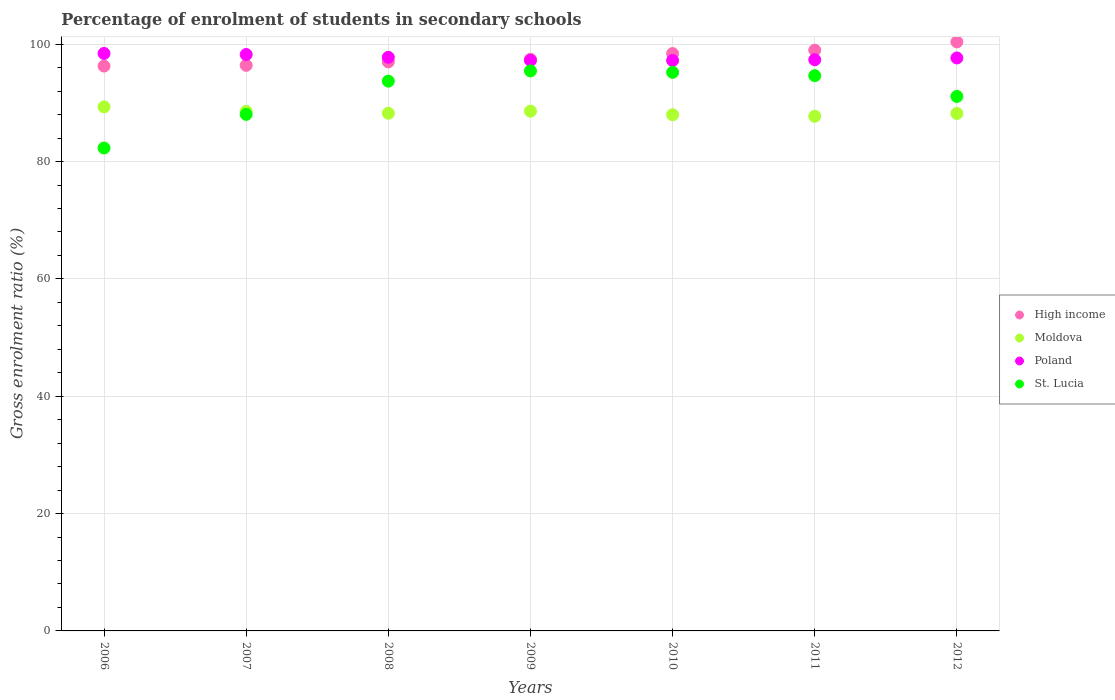Is the number of dotlines equal to the number of legend labels?
Offer a very short reply. Yes. What is the percentage of students enrolled in secondary schools in Moldova in 2007?
Offer a terse response. 88.55. Across all years, what is the maximum percentage of students enrolled in secondary schools in Poland?
Provide a succinct answer. 98.43. Across all years, what is the minimum percentage of students enrolled in secondary schools in Moldova?
Make the answer very short. 87.72. In which year was the percentage of students enrolled in secondary schools in St. Lucia maximum?
Provide a succinct answer. 2009. What is the total percentage of students enrolled in secondary schools in High income in the graph?
Your answer should be very brief. 684.9. What is the difference between the percentage of students enrolled in secondary schools in St. Lucia in 2006 and that in 2009?
Your response must be concise. -13.14. What is the difference between the percentage of students enrolled in secondary schools in Poland in 2006 and the percentage of students enrolled in secondary schools in St. Lucia in 2012?
Give a very brief answer. 7.33. What is the average percentage of students enrolled in secondary schools in St. Lucia per year?
Provide a succinct answer. 91.49. In the year 2009, what is the difference between the percentage of students enrolled in secondary schools in Moldova and percentage of students enrolled in secondary schools in St. Lucia?
Ensure brevity in your answer.  -6.85. In how many years, is the percentage of students enrolled in secondary schools in High income greater than 4 %?
Offer a terse response. 7. What is the ratio of the percentage of students enrolled in secondary schools in Poland in 2008 to that in 2009?
Provide a succinct answer. 1.01. Is the difference between the percentage of students enrolled in secondary schools in Moldova in 2008 and 2009 greater than the difference between the percentage of students enrolled in secondary schools in St. Lucia in 2008 and 2009?
Provide a short and direct response. Yes. What is the difference between the highest and the second highest percentage of students enrolled in secondary schools in Poland?
Your answer should be very brief. 0.18. What is the difference between the highest and the lowest percentage of students enrolled in secondary schools in Poland?
Offer a terse response. 1.21. In how many years, is the percentage of students enrolled in secondary schools in High income greater than the average percentage of students enrolled in secondary schools in High income taken over all years?
Ensure brevity in your answer.  3. Is it the case that in every year, the sum of the percentage of students enrolled in secondary schools in High income and percentage of students enrolled in secondary schools in Poland  is greater than the sum of percentage of students enrolled in secondary schools in Moldova and percentage of students enrolled in secondary schools in St. Lucia?
Give a very brief answer. Yes. Is the percentage of students enrolled in secondary schools in Moldova strictly greater than the percentage of students enrolled in secondary schools in Poland over the years?
Offer a very short reply. No. How many dotlines are there?
Make the answer very short. 4. Are the values on the major ticks of Y-axis written in scientific E-notation?
Your answer should be compact. No. Does the graph contain any zero values?
Your response must be concise. No. Where does the legend appear in the graph?
Your answer should be compact. Center right. How many legend labels are there?
Ensure brevity in your answer.  4. What is the title of the graph?
Your answer should be compact. Percentage of enrolment of students in secondary schools. What is the label or title of the X-axis?
Make the answer very short. Years. What is the Gross enrolment ratio (%) in High income in 2006?
Ensure brevity in your answer.  96.28. What is the Gross enrolment ratio (%) of Moldova in 2006?
Provide a short and direct response. 89.32. What is the Gross enrolment ratio (%) of Poland in 2006?
Ensure brevity in your answer.  98.43. What is the Gross enrolment ratio (%) in St. Lucia in 2006?
Your answer should be compact. 82.31. What is the Gross enrolment ratio (%) in High income in 2007?
Ensure brevity in your answer.  96.4. What is the Gross enrolment ratio (%) of Moldova in 2007?
Keep it short and to the point. 88.55. What is the Gross enrolment ratio (%) in Poland in 2007?
Your response must be concise. 98.25. What is the Gross enrolment ratio (%) in St. Lucia in 2007?
Offer a terse response. 88.04. What is the Gross enrolment ratio (%) in High income in 2008?
Keep it short and to the point. 96.99. What is the Gross enrolment ratio (%) in Moldova in 2008?
Your answer should be very brief. 88.23. What is the Gross enrolment ratio (%) in Poland in 2008?
Provide a succinct answer. 97.77. What is the Gross enrolment ratio (%) of St. Lucia in 2008?
Offer a very short reply. 93.71. What is the Gross enrolment ratio (%) of High income in 2009?
Your answer should be very brief. 97.44. What is the Gross enrolment ratio (%) of Moldova in 2009?
Offer a very short reply. 88.6. What is the Gross enrolment ratio (%) in Poland in 2009?
Provide a short and direct response. 97.25. What is the Gross enrolment ratio (%) in St. Lucia in 2009?
Ensure brevity in your answer.  95.45. What is the Gross enrolment ratio (%) of High income in 2010?
Your response must be concise. 98.41. What is the Gross enrolment ratio (%) in Moldova in 2010?
Your answer should be compact. 87.98. What is the Gross enrolment ratio (%) of Poland in 2010?
Your answer should be very brief. 97.22. What is the Gross enrolment ratio (%) of St. Lucia in 2010?
Your answer should be compact. 95.21. What is the Gross enrolment ratio (%) of High income in 2011?
Ensure brevity in your answer.  98.98. What is the Gross enrolment ratio (%) of Moldova in 2011?
Keep it short and to the point. 87.72. What is the Gross enrolment ratio (%) of Poland in 2011?
Provide a short and direct response. 97.36. What is the Gross enrolment ratio (%) in St. Lucia in 2011?
Make the answer very short. 94.64. What is the Gross enrolment ratio (%) in High income in 2012?
Offer a terse response. 100.4. What is the Gross enrolment ratio (%) in Moldova in 2012?
Your answer should be compact. 88.2. What is the Gross enrolment ratio (%) in Poland in 2012?
Offer a very short reply. 97.66. What is the Gross enrolment ratio (%) in St. Lucia in 2012?
Give a very brief answer. 91.1. Across all years, what is the maximum Gross enrolment ratio (%) in High income?
Your answer should be compact. 100.4. Across all years, what is the maximum Gross enrolment ratio (%) of Moldova?
Ensure brevity in your answer.  89.32. Across all years, what is the maximum Gross enrolment ratio (%) of Poland?
Offer a very short reply. 98.43. Across all years, what is the maximum Gross enrolment ratio (%) in St. Lucia?
Your answer should be compact. 95.45. Across all years, what is the minimum Gross enrolment ratio (%) of High income?
Your answer should be compact. 96.28. Across all years, what is the minimum Gross enrolment ratio (%) in Moldova?
Your response must be concise. 87.72. Across all years, what is the minimum Gross enrolment ratio (%) in Poland?
Keep it short and to the point. 97.22. Across all years, what is the minimum Gross enrolment ratio (%) of St. Lucia?
Your answer should be very brief. 82.31. What is the total Gross enrolment ratio (%) of High income in the graph?
Provide a succinct answer. 684.9. What is the total Gross enrolment ratio (%) of Moldova in the graph?
Your response must be concise. 618.6. What is the total Gross enrolment ratio (%) in Poland in the graph?
Your response must be concise. 683.93. What is the total Gross enrolment ratio (%) of St. Lucia in the graph?
Ensure brevity in your answer.  640.46. What is the difference between the Gross enrolment ratio (%) of High income in 2006 and that in 2007?
Your answer should be compact. -0.12. What is the difference between the Gross enrolment ratio (%) in Moldova in 2006 and that in 2007?
Make the answer very short. 0.77. What is the difference between the Gross enrolment ratio (%) in Poland in 2006 and that in 2007?
Give a very brief answer. 0.18. What is the difference between the Gross enrolment ratio (%) in St. Lucia in 2006 and that in 2007?
Your answer should be compact. -5.73. What is the difference between the Gross enrolment ratio (%) of High income in 2006 and that in 2008?
Offer a terse response. -0.71. What is the difference between the Gross enrolment ratio (%) of Moldova in 2006 and that in 2008?
Make the answer very short. 1.09. What is the difference between the Gross enrolment ratio (%) of Poland in 2006 and that in 2008?
Provide a short and direct response. 0.66. What is the difference between the Gross enrolment ratio (%) in St. Lucia in 2006 and that in 2008?
Provide a short and direct response. -11.4. What is the difference between the Gross enrolment ratio (%) of High income in 2006 and that in 2009?
Provide a succinct answer. -1.16. What is the difference between the Gross enrolment ratio (%) of Moldova in 2006 and that in 2009?
Make the answer very short. 0.73. What is the difference between the Gross enrolment ratio (%) of Poland in 2006 and that in 2009?
Provide a short and direct response. 1.18. What is the difference between the Gross enrolment ratio (%) of St. Lucia in 2006 and that in 2009?
Your answer should be very brief. -13.14. What is the difference between the Gross enrolment ratio (%) of High income in 2006 and that in 2010?
Provide a succinct answer. -2.13. What is the difference between the Gross enrolment ratio (%) of Moldova in 2006 and that in 2010?
Provide a succinct answer. 1.34. What is the difference between the Gross enrolment ratio (%) in Poland in 2006 and that in 2010?
Provide a succinct answer. 1.21. What is the difference between the Gross enrolment ratio (%) of St. Lucia in 2006 and that in 2010?
Your answer should be very brief. -12.9. What is the difference between the Gross enrolment ratio (%) of High income in 2006 and that in 2011?
Ensure brevity in your answer.  -2.71. What is the difference between the Gross enrolment ratio (%) of Moldova in 2006 and that in 2011?
Your answer should be very brief. 1.6. What is the difference between the Gross enrolment ratio (%) of Poland in 2006 and that in 2011?
Your answer should be compact. 1.07. What is the difference between the Gross enrolment ratio (%) of St. Lucia in 2006 and that in 2011?
Ensure brevity in your answer.  -12.33. What is the difference between the Gross enrolment ratio (%) in High income in 2006 and that in 2012?
Give a very brief answer. -4.12. What is the difference between the Gross enrolment ratio (%) in Moldova in 2006 and that in 2012?
Ensure brevity in your answer.  1.13. What is the difference between the Gross enrolment ratio (%) of Poland in 2006 and that in 2012?
Make the answer very short. 0.77. What is the difference between the Gross enrolment ratio (%) of St. Lucia in 2006 and that in 2012?
Your response must be concise. -8.79. What is the difference between the Gross enrolment ratio (%) of High income in 2007 and that in 2008?
Offer a very short reply. -0.59. What is the difference between the Gross enrolment ratio (%) in Moldova in 2007 and that in 2008?
Keep it short and to the point. 0.32. What is the difference between the Gross enrolment ratio (%) of Poland in 2007 and that in 2008?
Give a very brief answer. 0.47. What is the difference between the Gross enrolment ratio (%) of St. Lucia in 2007 and that in 2008?
Provide a succinct answer. -5.67. What is the difference between the Gross enrolment ratio (%) of High income in 2007 and that in 2009?
Offer a terse response. -1.04. What is the difference between the Gross enrolment ratio (%) in Moldova in 2007 and that in 2009?
Ensure brevity in your answer.  -0.04. What is the difference between the Gross enrolment ratio (%) in Poland in 2007 and that in 2009?
Ensure brevity in your answer.  1. What is the difference between the Gross enrolment ratio (%) in St. Lucia in 2007 and that in 2009?
Ensure brevity in your answer.  -7.41. What is the difference between the Gross enrolment ratio (%) of High income in 2007 and that in 2010?
Provide a short and direct response. -2.01. What is the difference between the Gross enrolment ratio (%) in Moldova in 2007 and that in 2010?
Give a very brief answer. 0.57. What is the difference between the Gross enrolment ratio (%) in Poland in 2007 and that in 2010?
Make the answer very short. 1.03. What is the difference between the Gross enrolment ratio (%) of St. Lucia in 2007 and that in 2010?
Provide a short and direct response. -7.17. What is the difference between the Gross enrolment ratio (%) of High income in 2007 and that in 2011?
Offer a terse response. -2.59. What is the difference between the Gross enrolment ratio (%) in Moldova in 2007 and that in 2011?
Keep it short and to the point. 0.83. What is the difference between the Gross enrolment ratio (%) of Poland in 2007 and that in 2011?
Provide a succinct answer. 0.89. What is the difference between the Gross enrolment ratio (%) of St. Lucia in 2007 and that in 2011?
Provide a short and direct response. -6.6. What is the difference between the Gross enrolment ratio (%) of High income in 2007 and that in 2012?
Provide a short and direct response. -4. What is the difference between the Gross enrolment ratio (%) of Moldova in 2007 and that in 2012?
Offer a very short reply. 0.36. What is the difference between the Gross enrolment ratio (%) of Poland in 2007 and that in 2012?
Give a very brief answer. 0.59. What is the difference between the Gross enrolment ratio (%) in St. Lucia in 2007 and that in 2012?
Make the answer very short. -3.06. What is the difference between the Gross enrolment ratio (%) in High income in 2008 and that in 2009?
Make the answer very short. -0.45. What is the difference between the Gross enrolment ratio (%) of Moldova in 2008 and that in 2009?
Give a very brief answer. -0.36. What is the difference between the Gross enrolment ratio (%) in Poland in 2008 and that in 2009?
Ensure brevity in your answer.  0.53. What is the difference between the Gross enrolment ratio (%) in St. Lucia in 2008 and that in 2009?
Provide a short and direct response. -1.74. What is the difference between the Gross enrolment ratio (%) in High income in 2008 and that in 2010?
Your response must be concise. -1.42. What is the difference between the Gross enrolment ratio (%) of Moldova in 2008 and that in 2010?
Keep it short and to the point. 0.25. What is the difference between the Gross enrolment ratio (%) in Poland in 2008 and that in 2010?
Make the answer very short. 0.55. What is the difference between the Gross enrolment ratio (%) in St. Lucia in 2008 and that in 2010?
Provide a short and direct response. -1.5. What is the difference between the Gross enrolment ratio (%) of High income in 2008 and that in 2011?
Provide a succinct answer. -1.99. What is the difference between the Gross enrolment ratio (%) in Moldova in 2008 and that in 2011?
Make the answer very short. 0.52. What is the difference between the Gross enrolment ratio (%) in Poland in 2008 and that in 2011?
Your answer should be very brief. 0.42. What is the difference between the Gross enrolment ratio (%) of St. Lucia in 2008 and that in 2011?
Keep it short and to the point. -0.93. What is the difference between the Gross enrolment ratio (%) in High income in 2008 and that in 2012?
Your response must be concise. -3.41. What is the difference between the Gross enrolment ratio (%) in Moldova in 2008 and that in 2012?
Provide a short and direct response. 0.04. What is the difference between the Gross enrolment ratio (%) in Poland in 2008 and that in 2012?
Offer a very short reply. 0.11. What is the difference between the Gross enrolment ratio (%) in St. Lucia in 2008 and that in 2012?
Offer a terse response. 2.61. What is the difference between the Gross enrolment ratio (%) of High income in 2009 and that in 2010?
Make the answer very short. -0.97. What is the difference between the Gross enrolment ratio (%) in Moldova in 2009 and that in 2010?
Provide a short and direct response. 0.62. What is the difference between the Gross enrolment ratio (%) in Poland in 2009 and that in 2010?
Provide a short and direct response. 0.02. What is the difference between the Gross enrolment ratio (%) of St. Lucia in 2009 and that in 2010?
Make the answer very short. 0.24. What is the difference between the Gross enrolment ratio (%) of High income in 2009 and that in 2011?
Ensure brevity in your answer.  -1.55. What is the difference between the Gross enrolment ratio (%) of Moldova in 2009 and that in 2011?
Make the answer very short. 0.88. What is the difference between the Gross enrolment ratio (%) in Poland in 2009 and that in 2011?
Make the answer very short. -0.11. What is the difference between the Gross enrolment ratio (%) in St. Lucia in 2009 and that in 2011?
Provide a succinct answer. 0.81. What is the difference between the Gross enrolment ratio (%) of High income in 2009 and that in 2012?
Provide a succinct answer. -2.96. What is the difference between the Gross enrolment ratio (%) of Moldova in 2009 and that in 2012?
Your response must be concise. 0.4. What is the difference between the Gross enrolment ratio (%) of Poland in 2009 and that in 2012?
Keep it short and to the point. -0.41. What is the difference between the Gross enrolment ratio (%) of St. Lucia in 2009 and that in 2012?
Keep it short and to the point. 4.35. What is the difference between the Gross enrolment ratio (%) of High income in 2010 and that in 2011?
Provide a succinct answer. -0.58. What is the difference between the Gross enrolment ratio (%) of Moldova in 2010 and that in 2011?
Keep it short and to the point. 0.26. What is the difference between the Gross enrolment ratio (%) of Poland in 2010 and that in 2011?
Your answer should be very brief. -0.13. What is the difference between the Gross enrolment ratio (%) of St. Lucia in 2010 and that in 2011?
Offer a terse response. 0.57. What is the difference between the Gross enrolment ratio (%) in High income in 2010 and that in 2012?
Provide a succinct answer. -1.99. What is the difference between the Gross enrolment ratio (%) of Moldova in 2010 and that in 2012?
Give a very brief answer. -0.21. What is the difference between the Gross enrolment ratio (%) of Poland in 2010 and that in 2012?
Give a very brief answer. -0.44. What is the difference between the Gross enrolment ratio (%) in St. Lucia in 2010 and that in 2012?
Provide a short and direct response. 4.11. What is the difference between the Gross enrolment ratio (%) of High income in 2011 and that in 2012?
Offer a terse response. -1.41. What is the difference between the Gross enrolment ratio (%) of Moldova in 2011 and that in 2012?
Your response must be concise. -0.48. What is the difference between the Gross enrolment ratio (%) of Poland in 2011 and that in 2012?
Keep it short and to the point. -0.3. What is the difference between the Gross enrolment ratio (%) in St. Lucia in 2011 and that in 2012?
Ensure brevity in your answer.  3.54. What is the difference between the Gross enrolment ratio (%) of High income in 2006 and the Gross enrolment ratio (%) of Moldova in 2007?
Give a very brief answer. 7.72. What is the difference between the Gross enrolment ratio (%) in High income in 2006 and the Gross enrolment ratio (%) in Poland in 2007?
Your answer should be compact. -1.97. What is the difference between the Gross enrolment ratio (%) in High income in 2006 and the Gross enrolment ratio (%) in St. Lucia in 2007?
Your response must be concise. 8.23. What is the difference between the Gross enrolment ratio (%) of Moldova in 2006 and the Gross enrolment ratio (%) of Poland in 2007?
Provide a succinct answer. -8.93. What is the difference between the Gross enrolment ratio (%) in Moldova in 2006 and the Gross enrolment ratio (%) in St. Lucia in 2007?
Your response must be concise. 1.28. What is the difference between the Gross enrolment ratio (%) in Poland in 2006 and the Gross enrolment ratio (%) in St. Lucia in 2007?
Provide a succinct answer. 10.38. What is the difference between the Gross enrolment ratio (%) in High income in 2006 and the Gross enrolment ratio (%) in Moldova in 2008?
Your answer should be compact. 8.04. What is the difference between the Gross enrolment ratio (%) of High income in 2006 and the Gross enrolment ratio (%) of Poland in 2008?
Offer a very short reply. -1.49. What is the difference between the Gross enrolment ratio (%) in High income in 2006 and the Gross enrolment ratio (%) in St. Lucia in 2008?
Your answer should be compact. 2.57. What is the difference between the Gross enrolment ratio (%) of Moldova in 2006 and the Gross enrolment ratio (%) of Poland in 2008?
Make the answer very short. -8.45. What is the difference between the Gross enrolment ratio (%) of Moldova in 2006 and the Gross enrolment ratio (%) of St. Lucia in 2008?
Your response must be concise. -4.39. What is the difference between the Gross enrolment ratio (%) of Poland in 2006 and the Gross enrolment ratio (%) of St. Lucia in 2008?
Provide a short and direct response. 4.72. What is the difference between the Gross enrolment ratio (%) of High income in 2006 and the Gross enrolment ratio (%) of Moldova in 2009?
Keep it short and to the point. 7.68. What is the difference between the Gross enrolment ratio (%) of High income in 2006 and the Gross enrolment ratio (%) of Poland in 2009?
Offer a terse response. -0.97. What is the difference between the Gross enrolment ratio (%) in High income in 2006 and the Gross enrolment ratio (%) in St. Lucia in 2009?
Your answer should be very brief. 0.83. What is the difference between the Gross enrolment ratio (%) of Moldova in 2006 and the Gross enrolment ratio (%) of Poland in 2009?
Your response must be concise. -7.92. What is the difference between the Gross enrolment ratio (%) of Moldova in 2006 and the Gross enrolment ratio (%) of St. Lucia in 2009?
Give a very brief answer. -6.13. What is the difference between the Gross enrolment ratio (%) in Poland in 2006 and the Gross enrolment ratio (%) in St. Lucia in 2009?
Offer a very short reply. 2.98. What is the difference between the Gross enrolment ratio (%) of High income in 2006 and the Gross enrolment ratio (%) of Moldova in 2010?
Keep it short and to the point. 8.3. What is the difference between the Gross enrolment ratio (%) in High income in 2006 and the Gross enrolment ratio (%) in Poland in 2010?
Make the answer very short. -0.94. What is the difference between the Gross enrolment ratio (%) of High income in 2006 and the Gross enrolment ratio (%) of St. Lucia in 2010?
Offer a very short reply. 1.07. What is the difference between the Gross enrolment ratio (%) in Moldova in 2006 and the Gross enrolment ratio (%) in Poland in 2010?
Offer a terse response. -7.9. What is the difference between the Gross enrolment ratio (%) in Moldova in 2006 and the Gross enrolment ratio (%) in St. Lucia in 2010?
Make the answer very short. -5.89. What is the difference between the Gross enrolment ratio (%) of Poland in 2006 and the Gross enrolment ratio (%) of St. Lucia in 2010?
Give a very brief answer. 3.22. What is the difference between the Gross enrolment ratio (%) in High income in 2006 and the Gross enrolment ratio (%) in Moldova in 2011?
Your answer should be compact. 8.56. What is the difference between the Gross enrolment ratio (%) of High income in 2006 and the Gross enrolment ratio (%) of Poland in 2011?
Keep it short and to the point. -1.08. What is the difference between the Gross enrolment ratio (%) in High income in 2006 and the Gross enrolment ratio (%) in St. Lucia in 2011?
Your response must be concise. 1.64. What is the difference between the Gross enrolment ratio (%) in Moldova in 2006 and the Gross enrolment ratio (%) in Poland in 2011?
Ensure brevity in your answer.  -8.03. What is the difference between the Gross enrolment ratio (%) in Moldova in 2006 and the Gross enrolment ratio (%) in St. Lucia in 2011?
Offer a terse response. -5.32. What is the difference between the Gross enrolment ratio (%) in Poland in 2006 and the Gross enrolment ratio (%) in St. Lucia in 2011?
Offer a very short reply. 3.79. What is the difference between the Gross enrolment ratio (%) in High income in 2006 and the Gross enrolment ratio (%) in Moldova in 2012?
Give a very brief answer. 8.08. What is the difference between the Gross enrolment ratio (%) in High income in 2006 and the Gross enrolment ratio (%) in Poland in 2012?
Provide a short and direct response. -1.38. What is the difference between the Gross enrolment ratio (%) of High income in 2006 and the Gross enrolment ratio (%) of St. Lucia in 2012?
Give a very brief answer. 5.18. What is the difference between the Gross enrolment ratio (%) in Moldova in 2006 and the Gross enrolment ratio (%) in Poland in 2012?
Your answer should be compact. -8.34. What is the difference between the Gross enrolment ratio (%) in Moldova in 2006 and the Gross enrolment ratio (%) in St. Lucia in 2012?
Make the answer very short. -1.78. What is the difference between the Gross enrolment ratio (%) of Poland in 2006 and the Gross enrolment ratio (%) of St. Lucia in 2012?
Give a very brief answer. 7.33. What is the difference between the Gross enrolment ratio (%) of High income in 2007 and the Gross enrolment ratio (%) of Moldova in 2008?
Provide a short and direct response. 8.16. What is the difference between the Gross enrolment ratio (%) of High income in 2007 and the Gross enrolment ratio (%) of Poland in 2008?
Offer a terse response. -1.37. What is the difference between the Gross enrolment ratio (%) of High income in 2007 and the Gross enrolment ratio (%) of St. Lucia in 2008?
Offer a very short reply. 2.69. What is the difference between the Gross enrolment ratio (%) in Moldova in 2007 and the Gross enrolment ratio (%) in Poland in 2008?
Ensure brevity in your answer.  -9.22. What is the difference between the Gross enrolment ratio (%) of Moldova in 2007 and the Gross enrolment ratio (%) of St. Lucia in 2008?
Your answer should be compact. -5.16. What is the difference between the Gross enrolment ratio (%) in Poland in 2007 and the Gross enrolment ratio (%) in St. Lucia in 2008?
Ensure brevity in your answer.  4.54. What is the difference between the Gross enrolment ratio (%) of High income in 2007 and the Gross enrolment ratio (%) of Moldova in 2009?
Offer a very short reply. 7.8. What is the difference between the Gross enrolment ratio (%) in High income in 2007 and the Gross enrolment ratio (%) in Poland in 2009?
Give a very brief answer. -0.85. What is the difference between the Gross enrolment ratio (%) of High income in 2007 and the Gross enrolment ratio (%) of St. Lucia in 2009?
Make the answer very short. 0.95. What is the difference between the Gross enrolment ratio (%) in Moldova in 2007 and the Gross enrolment ratio (%) in Poland in 2009?
Ensure brevity in your answer.  -8.69. What is the difference between the Gross enrolment ratio (%) of Moldova in 2007 and the Gross enrolment ratio (%) of St. Lucia in 2009?
Your answer should be very brief. -6.9. What is the difference between the Gross enrolment ratio (%) in Poland in 2007 and the Gross enrolment ratio (%) in St. Lucia in 2009?
Offer a very short reply. 2.8. What is the difference between the Gross enrolment ratio (%) of High income in 2007 and the Gross enrolment ratio (%) of Moldova in 2010?
Keep it short and to the point. 8.42. What is the difference between the Gross enrolment ratio (%) in High income in 2007 and the Gross enrolment ratio (%) in Poland in 2010?
Provide a succinct answer. -0.82. What is the difference between the Gross enrolment ratio (%) in High income in 2007 and the Gross enrolment ratio (%) in St. Lucia in 2010?
Your answer should be very brief. 1.19. What is the difference between the Gross enrolment ratio (%) in Moldova in 2007 and the Gross enrolment ratio (%) in Poland in 2010?
Offer a very short reply. -8.67. What is the difference between the Gross enrolment ratio (%) of Moldova in 2007 and the Gross enrolment ratio (%) of St. Lucia in 2010?
Offer a very short reply. -6.66. What is the difference between the Gross enrolment ratio (%) in Poland in 2007 and the Gross enrolment ratio (%) in St. Lucia in 2010?
Make the answer very short. 3.04. What is the difference between the Gross enrolment ratio (%) in High income in 2007 and the Gross enrolment ratio (%) in Moldova in 2011?
Offer a terse response. 8.68. What is the difference between the Gross enrolment ratio (%) of High income in 2007 and the Gross enrolment ratio (%) of Poland in 2011?
Your answer should be compact. -0.96. What is the difference between the Gross enrolment ratio (%) in High income in 2007 and the Gross enrolment ratio (%) in St. Lucia in 2011?
Offer a very short reply. 1.76. What is the difference between the Gross enrolment ratio (%) of Moldova in 2007 and the Gross enrolment ratio (%) of Poland in 2011?
Provide a succinct answer. -8.8. What is the difference between the Gross enrolment ratio (%) of Moldova in 2007 and the Gross enrolment ratio (%) of St. Lucia in 2011?
Your answer should be very brief. -6.09. What is the difference between the Gross enrolment ratio (%) in Poland in 2007 and the Gross enrolment ratio (%) in St. Lucia in 2011?
Ensure brevity in your answer.  3.61. What is the difference between the Gross enrolment ratio (%) in High income in 2007 and the Gross enrolment ratio (%) in Moldova in 2012?
Your answer should be very brief. 8.2. What is the difference between the Gross enrolment ratio (%) of High income in 2007 and the Gross enrolment ratio (%) of Poland in 2012?
Ensure brevity in your answer.  -1.26. What is the difference between the Gross enrolment ratio (%) of High income in 2007 and the Gross enrolment ratio (%) of St. Lucia in 2012?
Ensure brevity in your answer.  5.3. What is the difference between the Gross enrolment ratio (%) in Moldova in 2007 and the Gross enrolment ratio (%) in Poland in 2012?
Your answer should be very brief. -9.1. What is the difference between the Gross enrolment ratio (%) in Moldova in 2007 and the Gross enrolment ratio (%) in St. Lucia in 2012?
Offer a very short reply. -2.55. What is the difference between the Gross enrolment ratio (%) of Poland in 2007 and the Gross enrolment ratio (%) of St. Lucia in 2012?
Your response must be concise. 7.15. What is the difference between the Gross enrolment ratio (%) of High income in 2008 and the Gross enrolment ratio (%) of Moldova in 2009?
Offer a very short reply. 8.39. What is the difference between the Gross enrolment ratio (%) in High income in 2008 and the Gross enrolment ratio (%) in Poland in 2009?
Keep it short and to the point. -0.25. What is the difference between the Gross enrolment ratio (%) of High income in 2008 and the Gross enrolment ratio (%) of St. Lucia in 2009?
Provide a succinct answer. 1.54. What is the difference between the Gross enrolment ratio (%) of Moldova in 2008 and the Gross enrolment ratio (%) of Poland in 2009?
Your answer should be very brief. -9.01. What is the difference between the Gross enrolment ratio (%) in Moldova in 2008 and the Gross enrolment ratio (%) in St. Lucia in 2009?
Offer a terse response. -7.21. What is the difference between the Gross enrolment ratio (%) of Poland in 2008 and the Gross enrolment ratio (%) of St. Lucia in 2009?
Give a very brief answer. 2.32. What is the difference between the Gross enrolment ratio (%) in High income in 2008 and the Gross enrolment ratio (%) in Moldova in 2010?
Ensure brevity in your answer.  9.01. What is the difference between the Gross enrolment ratio (%) of High income in 2008 and the Gross enrolment ratio (%) of Poland in 2010?
Provide a short and direct response. -0.23. What is the difference between the Gross enrolment ratio (%) of High income in 2008 and the Gross enrolment ratio (%) of St. Lucia in 2010?
Make the answer very short. 1.78. What is the difference between the Gross enrolment ratio (%) of Moldova in 2008 and the Gross enrolment ratio (%) of Poland in 2010?
Offer a very short reply. -8.99. What is the difference between the Gross enrolment ratio (%) in Moldova in 2008 and the Gross enrolment ratio (%) in St. Lucia in 2010?
Offer a very short reply. -6.97. What is the difference between the Gross enrolment ratio (%) in Poland in 2008 and the Gross enrolment ratio (%) in St. Lucia in 2010?
Keep it short and to the point. 2.56. What is the difference between the Gross enrolment ratio (%) of High income in 2008 and the Gross enrolment ratio (%) of Moldova in 2011?
Offer a very short reply. 9.27. What is the difference between the Gross enrolment ratio (%) in High income in 2008 and the Gross enrolment ratio (%) in Poland in 2011?
Offer a terse response. -0.36. What is the difference between the Gross enrolment ratio (%) of High income in 2008 and the Gross enrolment ratio (%) of St. Lucia in 2011?
Make the answer very short. 2.35. What is the difference between the Gross enrolment ratio (%) of Moldova in 2008 and the Gross enrolment ratio (%) of Poland in 2011?
Offer a very short reply. -9.12. What is the difference between the Gross enrolment ratio (%) of Moldova in 2008 and the Gross enrolment ratio (%) of St. Lucia in 2011?
Your answer should be very brief. -6.41. What is the difference between the Gross enrolment ratio (%) in Poland in 2008 and the Gross enrolment ratio (%) in St. Lucia in 2011?
Your response must be concise. 3.13. What is the difference between the Gross enrolment ratio (%) in High income in 2008 and the Gross enrolment ratio (%) in Moldova in 2012?
Give a very brief answer. 8.8. What is the difference between the Gross enrolment ratio (%) of High income in 2008 and the Gross enrolment ratio (%) of Poland in 2012?
Offer a terse response. -0.67. What is the difference between the Gross enrolment ratio (%) in High income in 2008 and the Gross enrolment ratio (%) in St. Lucia in 2012?
Ensure brevity in your answer.  5.89. What is the difference between the Gross enrolment ratio (%) of Moldova in 2008 and the Gross enrolment ratio (%) of Poland in 2012?
Offer a terse response. -9.42. What is the difference between the Gross enrolment ratio (%) in Moldova in 2008 and the Gross enrolment ratio (%) in St. Lucia in 2012?
Offer a terse response. -2.87. What is the difference between the Gross enrolment ratio (%) in Poland in 2008 and the Gross enrolment ratio (%) in St. Lucia in 2012?
Offer a terse response. 6.67. What is the difference between the Gross enrolment ratio (%) in High income in 2009 and the Gross enrolment ratio (%) in Moldova in 2010?
Your answer should be very brief. 9.46. What is the difference between the Gross enrolment ratio (%) in High income in 2009 and the Gross enrolment ratio (%) in Poland in 2010?
Provide a succinct answer. 0.21. What is the difference between the Gross enrolment ratio (%) of High income in 2009 and the Gross enrolment ratio (%) of St. Lucia in 2010?
Provide a succinct answer. 2.23. What is the difference between the Gross enrolment ratio (%) in Moldova in 2009 and the Gross enrolment ratio (%) in Poland in 2010?
Offer a very short reply. -8.63. What is the difference between the Gross enrolment ratio (%) of Moldova in 2009 and the Gross enrolment ratio (%) of St. Lucia in 2010?
Your answer should be compact. -6.61. What is the difference between the Gross enrolment ratio (%) in Poland in 2009 and the Gross enrolment ratio (%) in St. Lucia in 2010?
Your answer should be compact. 2.04. What is the difference between the Gross enrolment ratio (%) of High income in 2009 and the Gross enrolment ratio (%) of Moldova in 2011?
Your answer should be compact. 9.72. What is the difference between the Gross enrolment ratio (%) of High income in 2009 and the Gross enrolment ratio (%) of Poland in 2011?
Provide a succinct answer. 0.08. What is the difference between the Gross enrolment ratio (%) of High income in 2009 and the Gross enrolment ratio (%) of St. Lucia in 2011?
Make the answer very short. 2.8. What is the difference between the Gross enrolment ratio (%) of Moldova in 2009 and the Gross enrolment ratio (%) of Poland in 2011?
Your response must be concise. -8.76. What is the difference between the Gross enrolment ratio (%) of Moldova in 2009 and the Gross enrolment ratio (%) of St. Lucia in 2011?
Provide a short and direct response. -6.04. What is the difference between the Gross enrolment ratio (%) in Poland in 2009 and the Gross enrolment ratio (%) in St. Lucia in 2011?
Your answer should be compact. 2.61. What is the difference between the Gross enrolment ratio (%) of High income in 2009 and the Gross enrolment ratio (%) of Moldova in 2012?
Offer a terse response. 9.24. What is the difference between the Gross enrolment ratio (%) in High income in 2009 and the Gross enrolment ratio (%) in Poland in 2012?
Keep it short and to the point. -0.22. What is the difference between the Gross enrolment ratio (%) in High income in 2009 and the Gross enrolment ratio (%) in St. Lucia in 2012?
Provide a succinct answer. 6.34. What is the difference between the Gross enrolment ratio (%) in Moldova in 2009 and the Gross enrolment ratio (%) in Poland in 2012?
Keep it short and to the point. -9.06. What is the difference between the Gross enrolment ratio (%) of Moldova in 2009 and the Gross enrolment ratio (%) of St. Lucia in 2012?
Give a very brief answer. -2.5. What is the difference between the Gross enrolment ratio (%) of Poland in 2009 and the Gross enrolment ratio (%) of St. Lucia in 2012?
Ensure brevity in your answer.  6.14. What is the difference between the Gross enrolment ratio (%) in High income in 2010 and the Gross enrolment ratio (%) in Moldova in 2011?
Your answer should be compact. 10.69. What is the difference between the Gross enrolment ratio (%) in High income in 2010 and the Gross enrolment ratio (%) in Poland in 2011?
Your response must be concise. 1.05. What is the difference between the Gross enrolment ratio (%) of High income in 2010 and the Gross enrolment ratio (%) of St. Lucia in 2011?
Your response must be concise. 3.77. What is the difference between the Gross enrolment ratio (%) in Moldova in 2010 and the Gross enrolment ratio (%) in Poland in 2011?
Make the answer very short. -9.37. What is the difference between the Gross enrolment ratio (%) of Moldova in 2010 and the Gross enrolment ratio (%) of St. Lucia in 2011?
Ensure brevity in your answer.  -6.66. What is the difference between the Gross enrolment ratio (%) of Poland in 2010 and the Gross enrolment ratio (%) of St. Lucia in 2011?
Give a very brief answer. 2.58. What is the difference between the Gross enrolment ratio (%) of High income in 2010 and the Gross enrolment ratio (%) of Moldova in 2012?
Ensure brevity in your answer.  10.21. What is the difference between the Gross enrolment ratio (%) of High income in 2010 and the Gross enrolment ratio (%) of Poland in 2012?
Provide a short and direct response. 0.75. What is the difference between the Gross enrolment ratio (%) of High income in 2010 and the Gross enrolment ratio (%) of St. Lucia in 2012?
Provide a short and direct response. 7.31. What is the difference between the Gross enrolment ratio (%) in Moldova in 2010 and the Gross enrolment ratio (%) in Poland in 2012?
Your response must be concise. -9.68. What is the difference between the Gross enrolment ratio (%) in Moldova in 2010 and the Gross enrolment ratio (%) in St. Lucia in 2012?
Your answer should be very brief. -3.12. What is the difference between the Gross enrolment ratio (%) of Poland in 2010 and the Gross enrolment ratio (%) of St. Lucia in 2012?
Make the answer very short. 6.12. What is the difference between the Gross enrolment ratio (%) of High income in 2011 and the Gross enrolment ratio (%) of Moldova in 2012?
Your response must be concise. 10.79. What is the difference between the Gross enrolment ratio (%) of High income in 2011 and the Gross enrolment ratio (%) of Poland in 2012?
Ensure brevity in your answer.  1.33. What is the difference between the Gross enrolment ratio (%) of High income in 2011 and the Gross enrolment ratio (%) of St. Lucia in 2012?
Make the answer very short. 7.88. What is the difference between the Gross enrolment ratio (%) of Moldova in 2011 and the Gross enrolment ratio (%) of Poland in 2012?
Provide a succinct answer. -9.94. What is the difference between the Gross enrolment ratio (%) in Moldova in 2011 and the Gross enrolment ratio (%) in St. Lucia in 2012?
Give a very brief answer. -3.38. What is the difference between the Gross enrolment ratio (%) in Poland in 2011 and the Gross enrolment ratio (%) in St. Lucia in 2012?
Your answer should be compact. 6.25. What is the average Gross enrolment ratio (%) in High income per year?
Provide a succinct answer. 97.84. What is the average Gross enrolment ratio (%) of Moldova per year?
Offer a terse response. 88.37. What is the average Gross enrolment ratio (%) of Poland per year?
Your answer should be compact. 97.7. What is the average Gross enrolment ratio (%) in St. Lucia per year?
Offer a terse response. 91.49. In the year 2006, what is the difference between the Gross enrolment ratio (%) of High income and Gross enrolment ratio (%) of Moldova?
Keep it short and to the point. 6.96. In the year 2006, what is the difference between the Gross enrolment ratio (%) of High income and Gross enrolment ratio (%) of Poland?
Give a very brief answer. -2.15. In the year 2006, what is the difference between the Gross enrolment ratio (%) in High income and Gross enrolment ratio (%) in St. Lucia?
Your response must be concise. 13.97. In the year 2006, what is the difference between the Gross enrolment ratio (%) of Moldova and Gross enrolment ratio (%) of Poland?
Give a very brief answer. -9.11. In the year 2006, what is the difference between the Gross enrolment ratio (%) of Moldova and Gross enrolment ratio (%) of St. Lucia?
Your answer should be very brief. 7.01. In the year 2006, what is the difference between the Gross enrolment ratio (%) of Poland and Gross enrolment ratio (%) of St. Lucia?
Give a very brief answer. 16.12. In the year 2007, what is the difference between the Gross enrolment ratio (%) in High income and Gross enrolment ratio (%) in Moldova?
Make the answer very short. 7.85. In the year 2007, what is the difference between the Gross enrolment ratio (%) in High income and Gross enrolment ratio (%) in Poland?
Offer a terse response. -1.85. In the year 2007, what is the difference between the Gross enrolment ratio (%) of High income and Gross enrolment ratio (%) of St. Lucia?
Your answer should be very brief. 8.36. In the year 2007, what is the difference between the Gross enrolment ratio (%) of Moldova and Gross enrolment ratio (%) of Poland?
Provide a short and direct response. -9.69. In the year 2007, what is the difference between the Gross enrolment ratio (%) in Moldova and Gross enrolment ratio (%) in St. Lucia?
Keep it short and to the point. 0.51. In the year 2007, what is the difference between the Gross enrolment ratio (%) in Poland and Gross enrolment ratio (%) in St. Lucia?
Make the answer very short. 10.2. In the year 2008, what is the difference between the Gross enrolment ratio (%) of High income and Gross enrolment ratio (%) of Moldova?
Give a very brief answer. 8.76. In the year 2008, what is the difference between the Gross enrolment ratio (%) of High income and Gross enrolment ratio (%) of Poland?
Provide a short and direct response. -0.78. In the year 2008, what is the difference between the Gross enrolment ratio (%) in High income and Gross enrolment ratio (%) in St. Lucia?
Make the answer very short. 3.28. In the year 2008, what is the difference between the Gross enrolment ratio (%) in Moldova and Gross enrolment ratio (%) in Poland?
Offer a terse response. -9.54. In the year 2008, what is the difference between the Gross enrolment ratio (%) of Moldova and Gross enrolment ratio (%) of St. Lucia?
Ensure brevity in your answer.  -5.47. In the year 2008, what is the difference between the Gross enrolment ratio (%) in Poland and Gross enrolment ratio (%) in St. Lucia?
Provide a succinct answer. 4.06. In the year 2009, what is the difference between the Gross enrolment ratio (%) of High income and Gross enrolment ratio (%) of Moldova?
Your answer should be compact. 8.84. In the year 2009, what is the difference between the Gross enrolment ratio (%) in High income and Gross enrolment ratio (%) in Poland?
Make the answer very short. 0.19. In the year 2009, what is the difference between the Gross enrolment ratio (%) of High income and Gross enrolment ratio (%) of St. Lucia?
Give a very brief answer. 1.99. In the year 2009, what is the difference between the Gross enrolment ratio (%) of Moldova and Gross enrolment ratio (%) of Poland?
Provide a short and direct response. -8.65. In the year 2009, what is the difference between the Gross enrolment ratio (%) of Moldova and Gross enrolment ratio (%) of St. Lucia?
Keep it short and to the point. -6.85. In the year 2009, what is the difference between the Gross enrolment ratio (%) of Poland and Gross enrolment ratio (%) of St. Lucia?
Keep it short and to the point. 1.8. In the year 2010, what is the difference between the Gross enrolment ratio (%) of High income and Gross enrolment ratio (%) of Moldova?
Your answer should be compact. 10.43. In the year 2010, what is the difference between the Gross enrolment ratio (%) in High income and Gross enrolment ratio (%) in Poland?
Ensure brevity in your answer.  1.19. In the year 2010, what is the difference between the Gross enrolment ratio (%) in High income and Gross enrolment ratio (%) in St. Lucia?
Provide a short and direct response. 3.2. In the year 2010, what is the difference between the Gross enrolment ratio (%) of Moldova and Gross enrolment ratio (%) of Poland?
Your response must be concise. -9.24. In the year 2010, what is the difference between the Gross enrolment ratio (%) of Moldova and Gross enrolment ratio (%) of St. Lucia?
Provide a short and direct response. -7.23. In the year 2010, what is the difference between the Gross enrolment ratio (%) in Poland and Gross enrolment ratio (%) in St. Lucia?
Your answer should be very brief. 2.01. In the year 2011, what is the difference between the Gross enrolment ratio (%) in High income and Gross enrolment ratio (%) in Moldova?
Keep it short and to the point. 11.27. In the year 2011, what is the difference between the Gross enrolment ratio (%) of High income and Gross enrolment ratio (%) of Poland?
Offer a very short reply. 1.63. In the year 2011, what is the difference between the Gross enrolment ratio (%) of High income and Gross enrolment ratio (%) of St. Lucia?
Make the answer very short. 4.34. In the year 2011, what is the difference between the Gross enrolment ratio (%) of Moldova and Gross enrolment ratio (%) of Poland?
Keep it short and to the point. -9.64. In the year 2011, what is the difference between the Gross enrolment ratio (%) in Moldova and Gross enrolment ratio (%) in St. Lucia?
Make the answer very short. -6.92. In the year 2011, what is the difference between the Gross enrolment ratio (%) in Poland and Gross enrolment ratio (%) in St. Lucia?
Keep it short and to the point. 2.72. In the year 2012, what is the difference between the Gross enrolment ratio (%) in High income and Gross enrolment ratio (%) in Moldova?
Ensure brevity in your answer.  12.2. In the year 2012, what is the difference between the Gross enrolment ratio (%) in High income and Gross enrolment ratio (%) in Poland?
Offer a very short reply. 2.74. In the year 2012, what is the difference between the Gross enrolment ratio (%) in High income and Gross enrolment ratio (%) in St. Lucia?
Offer a terse response. 9.3. In the year 2012, what is the difference between the Gross enrolment ratio (%) in Moldova and Gross enrolment ratio (%) in Poland?
Give a very brief answer. -9.46. In the year 2012, what is the difference between the Gross enrolment ratio (%) of Moldova and Gross enrolment ratio (%) of St. Lucia?
Offer a very short reply. -2.91. In the year 2012, what is the difference between the Gross enrolment ratio (%) of Poland and Gross enrolment ratio (%) of St. Lucia?
Keep it short and to the point. 6.56. What is the ratio of the Gross enrolment ratio (%) of Moldova in 2006 to that in 2007?
Your answer should be very brief. 1.01. What is the ratio of the Gross enrolment ratio (%) in Poland in 2006 to that in 2007?
Give a very brief answer. 1. What is the ratio of the Gross enrolment ratio (%) of St. Lucia in 2006 to that in 2007?
Offer a very short reply. 0.93. What is the ratio of the Gross enrolment ratio (%) in Moldova in 2006 to that in 2008?
Keep it short and to the point. 1.01. What is the ratio of the Gross enrolment ratio (%) in St. Lucia in 2006 to that in 2008?
Offer a very short reply. 0.88. What is the ratio of the Gross enrolment ratio (%) of Moldova in 2006 to that in 2009?
Your answer should be compact. 1.01. What is the ratio of the Gross enrolment ratio (%) in Poland in 2006 to that in 2009?
Offer a terse response. 1.01. What is the ratio of the Gross enrolment ratio (%) in St. Lucia in 2006 to that in 2009?
Your answer should be very brief. 0.86. What is the ratio of the Gross enrolment ratio (%) of High income in 2006 to that in 2010?
Ensure brevity in your answer.  0.98. What is the ratio of the Gross enrolment ratio (%) in Moldova in 2006 to that in 2010?
Give a very brief answer. 1.02. What is the ratio of the Gross enrolment ratio (%) of Poland in 2006 to that in 2010?
Your answer should be very brief. 1.01. What is the ratio of the Gross enrolment ratio (%) of St. Lucia in 2006 to that in 2010?
Give a very brief answer. 0.86. What is the ratio of the Gross enrolment ratio (%) in High income in 2006 to that in 2011?
Your response must be concise. 0.97. What is the ratio of the Gross enrolment ratio (%) of Moldova in 2006 to that in 2011?
Keep it short and to the point. 1.02. What is the ratio of the Gross enrolment ratio (%) in St. Lucia in 2006 to that in 2011?
Offer a very short reply. 0.87. What is the ratio of the Gross enrolment ratio (%) in High income in 2006 to that in 2012?
Your answer should be very brief. 0.96. What is the ratio of the Gross enrolment ratio (%) in Moldova in 2006 to that in 2012?
Make the answer very short. 1.01. What is the ratio of the Gross enrolment ratio (%) of Poland in 2006 to that in 2012?
Your response must be concise. 1.01. What is the ratio of the Gross enrolment ratio (%) in St. Lucia in 2006 to that in 2012?
Your answer should be very brief. 0.9. What is the ratio of the Gross enrolment ratio (%) of High income in 2007 to that in 2008?
Provide a short and direct response. 0.99. What is the ratio of the Gross enrolment ratio (%) in Moldova in 2007 to that in 2008?
Give a very brief answer. 1. What is the ratio of the Gross enrolment ratio (%) of Poland in 2007 to that in 2008?
Give a very brief answer. 1. What is the ratio of the Gross enrolment ratio (%) of St. Lucia in 2007 to that in 2008?
Provide a short and direct response. 0.94. What is the ratio of the Gross enrolment ratio (%) in High income in 2007 to that in 2009?
Your response must be concise. 0.99. What is the ratio of the Gross enrolment ratio (%) in Poland in 2007 to that in 2009?
Your response must be concise. 1.01. What is the ratio of the Gross enrolment ratio (%) of St. Lucia in 2007 to that in 2009?
Offer a terse response. 0.92. What is the ratio of the Gross enrolment ratio (%) in High income in 2007 to that in 2010?
Your answer should be very brief. 0.98. What is the ratio of the Gross enrolment ratio (%) of Moldova in 2007 to that in 2010?
Your answer should be very brief. 1.01. What is the ratio of the Gross enrolment ratio (%) in Poland in 2007 to that in 2010?
Ensure brevity in your answer.  1.01. What is the ratio of the Gross enrolment ratio (%) of St. Lucia in 2007 to that in 2010?
Keep it short and to the point. 0.92. What is the ratio of the Gross enrolment ratio (%) of High income in 2007 to that in 2011?
Your answer should be very brief. 0.97. What is the ratio of the Gross enrolment ratio (%) of Moldova in 2007 to that in 2011?
Your answer should be very brief. 1.01. What is the ratio of the Gross enrolment ratio (%) in Poland in 2007 to that in 2011?
Provide a succinct answer. 1.01. What is the ratio of the Gross enrolment ratio (%) of St. Lucia in 2007 to that in 2011?
Your answer should be compact. 0.93. What is the ratio of the Gross enrolment ratio (%) of High income in 2007 to that in 2012?
Give a very brief answer. 0.96. What is the ratio of the Gross enrolment ratio (%) of Poland in 2007 to that in 2012?
Provide a short and direct response. 1.01. What is the ratio of the Gross enrolment ratio (%) of St. Lucia in 2007 to that in 2012?
Your answer should be very brief. 0.97. What is the ratio of the Gross enrolment ratio (%) in Moldova in 2008 to that in 2009?
Give a very brief answer. 1. What is the ratio of the Gross enrolment ratio (%) of Poland in 2008 to that in 2009?
Make the answer very short. 1.01. What is the ratio of the Gross enrolment ratio (%) of St. Lucia in 2008 to that in 2009?
Your answer should be compact. 0.98. What is the ratio of the Gross enrolment ratio (%) in High income in 2008 to that in 2010?
Make the answer very short. 0.99. What is the ratio of the Gross enrolment ratio (%) of Moldova in 2008 to that in 2010?
Give a very brief answer. 1. What is the ratio of the Gross enrolment ratio (%) in St. Lucia in 2008 to that in 2010?
Provide a succinct answer. 0.98. What is the ratio of the Gross enrolment ratio (%) of High income in 2008 to that in 2011?
Provide a short and direct response. 0.98. What is the ratio of the Gross enrolment ratio (%) of Moldova in 2008 to that in 2011?
Offer a terse response. 1.01. What is the ratio of the Gross enrolment ratio (%) of Poland in 2008 to that in 2011?
Your response must be concise. 1. What is the ratio of the Gross enrolment ratio (%) of St. Lucia in 2008 to that in 2011?
Provide a succinct answer. 0.99. What is the ratio of the Gross enrolment ratio (%) of High income in 2008 to that in 2012?
Offer a very short reply. 0.97. What is the ratio of the Gross enrolment ratio (%) of Moldova in 2008 to that in 2012?
Offer a terse response. 1. What is the ratio of the Gross enrolment ratio (%) of Poland in 2008 to that in 2012?
Ensure brevity in your answer.  1. What is the ratio of the Gross enrolment ratio (%) of St. Lucia in 2008 to that in 2012?
Your answer should be compact. 1.03. What is the ratio of the Gross enrolment ratio (%) in Moldova in 2009 to that in 2010?
Keep it short and to the point. 1.01. What is the ratio of the Gross enrolment ratio (%) in High income in 2009 to that in 2011?
Offer a very short reply. 0.98. What is the ratio of the Gross enrolment ratio (%) of Moldova in 2009 to that in 2011?
Provide a short and direct response. 1.01. What is the ratio of the Gross enrolment ratio (%) of Poland in 2009 to that in 2011?
Your answer should be compact. 1. What is the ratio of the Gross enrolment ratio (%) of St. Lucia in 2009 to that in 2011?
Your answer should be compact. 1.01. What is the ratio of the Gross enrolment ratio (%) of High income in 2009 to that in 2012?
Make the answer very short. 0.97. What is the ratio of the Gross enrolment ratio (%) in St. Lucia in 2009 to that in 2012?
Your answer should be very brief. 1.05. What is the ratio of the Gross enrolment ratio (%) of Poland in 2010 to that in 2011?
Offer a terse response. 1. What is the ratio of the Gross enrolment ratio (%) in St. Lucia in 2010 to that in 2011?
Provide a succinct answer. 1.01. What is the ratio of the Gross enrolment ratio (%) of High income in 2010 to that in 2012?
Your answer should be compact. 0.98. What is the ratio of the Gross enrolment ratio (%) in Moldova in 2010 to that in 2012?
Provide a succinct answer. 1. What is the ratio of the Gross enrolment ratio (%) in St. Lucia in 2010 to that in 2012?
Your response must be concise. 1.05. What is the ratio of the Gross enrolment ratio (%) of High income in 2011 to that in 2012?
Provide a short and direct response. 0.99. What is the ratio of the Gross enrolment ratio (%) of Poland in 2011 to that in 2012?
Ensure brevity in your answer.  1. What is the ratio of the Gross enrolment ratio (%) in St. Lucia in 2011 to that in 2012?
Your answer should be compact. 1.04. What is the difference between the highest and the second highest Gross enrolment ratio (%) in High income?
Ensure brevity in your answer.  1.41. What is the difference between the highest and the second highest Gross enrolment ratio (%) of Moldova?
Give a very brief answer. 0.73. What is the difference between the highest and the second highest Gross enrolment ratio (%) of Poland?
Keep it short and to the point. 0.18. What is the difference between the highest and the second highest Gross enrolment ratio (%) of St. Lucia?
Provide a short and direct response. 0.24. What is the difference between the highest and the lowest Gross enrolment ratio (%) of High income?
Keep it short and to the point. 4.12. What is the difference between the highest and the lowest Gross enrolment ratio (%) in Moldova?
Provide a succinct answer. 1.6. What is the difference between the highest and the lowest Gross enrolment ratio (%) of Poland?
Your answer should be compact. 1.21. What is the difference between the highest and the lowest Gross enrolment ratio (%) of St. Lucia?
Your response must be concise. 13.14. 